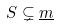<formula> <loc_0><loc_0><loc_500><loc_500>S \subsetneq \underline { m }</formula> 